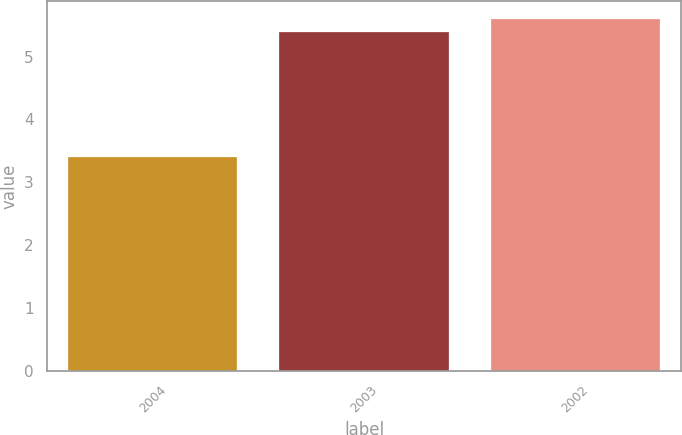Convert chart. <chart><loc_0><loc_0><loc_500><loc_500><bar_chart><fcel>2004<fcel>2003<fcel>2002<nl><fcel>3.4<fcel>5.4<fcel>5.6<nl></chart> 